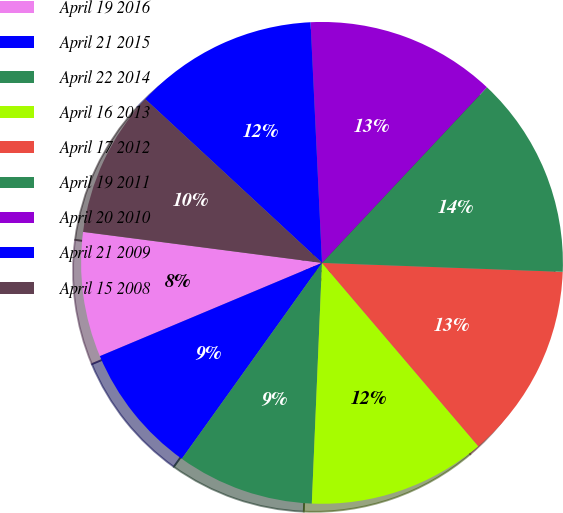<chart> <loc_0><loc_0><loc_500><loc_500><pie_chart><fcel>April 19 2016<fcel>April 21 2015<fcel>April 22 2014<fcel>April 16 2013<fcel>April 17 2012<fcel>April 19 2011<fcel>April 20 2010<fcel>April 21 2009<fcel>April 15 2008<nl><fcel>8.38%<fcel>8.79%<fcel>9.21%<fcel>11.91%<fcel>13.17%<fcel>13.59%<fcel>12.76%<fcel>12.35%<fcel>9.84%<nl></chart> 